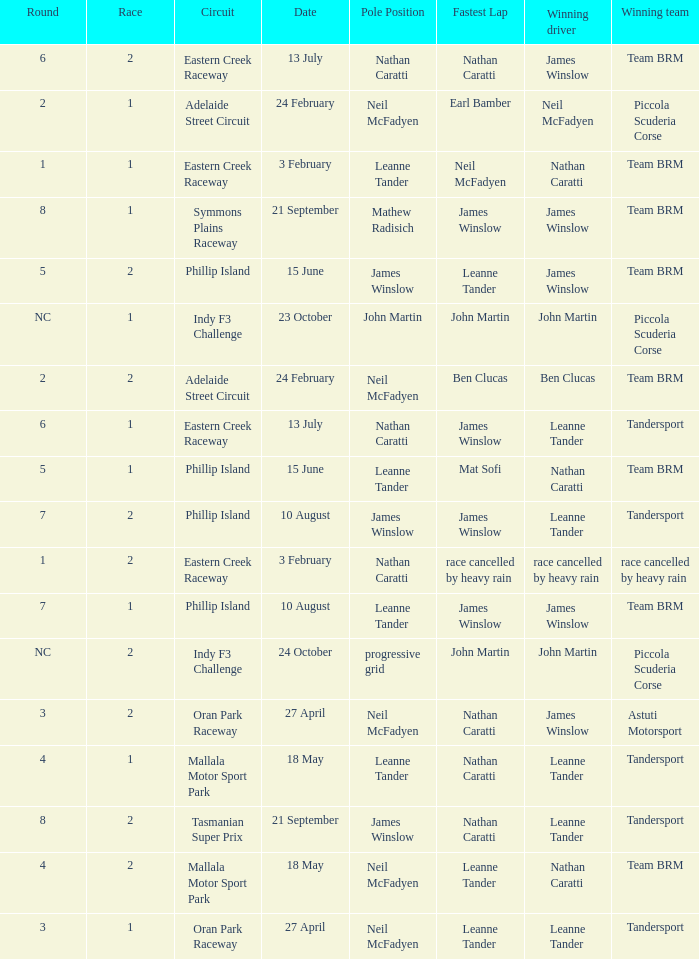Which race number in the Indy F3 Challenge circuit had John Martin in pole position? 1.0. 